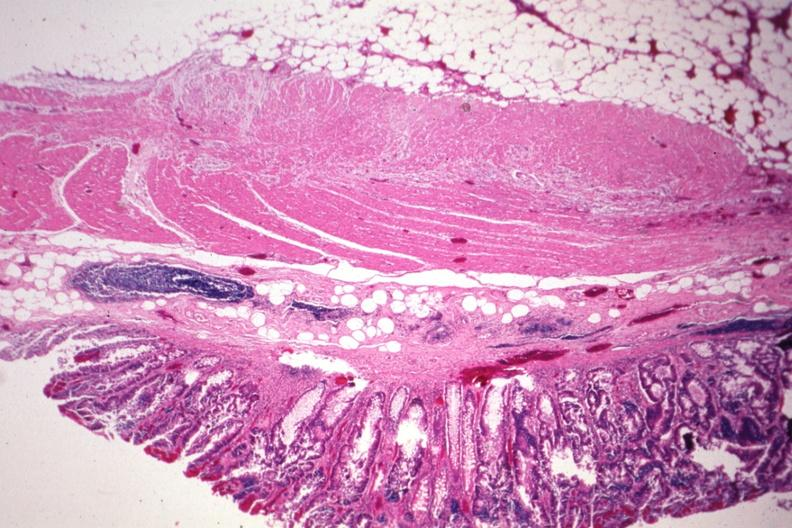s colon present?
Answer the question using a single word or phrase. Yes 